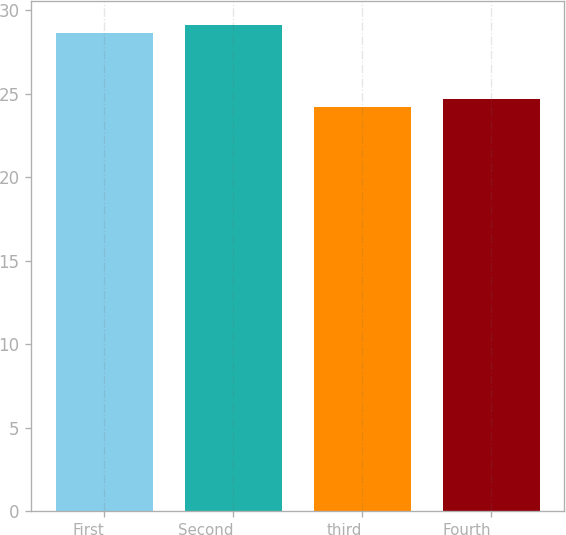Convert chart to OTSL. <chart><loc_0><loc_0><loc_500><loc_500><bar_chart><fcel>First<fcel>Second<fcel>third<fcel>Fourth<nl><fcel>28.66<fcel>29.12<fcel>24.22<fcel>24.69<nl></chart> 